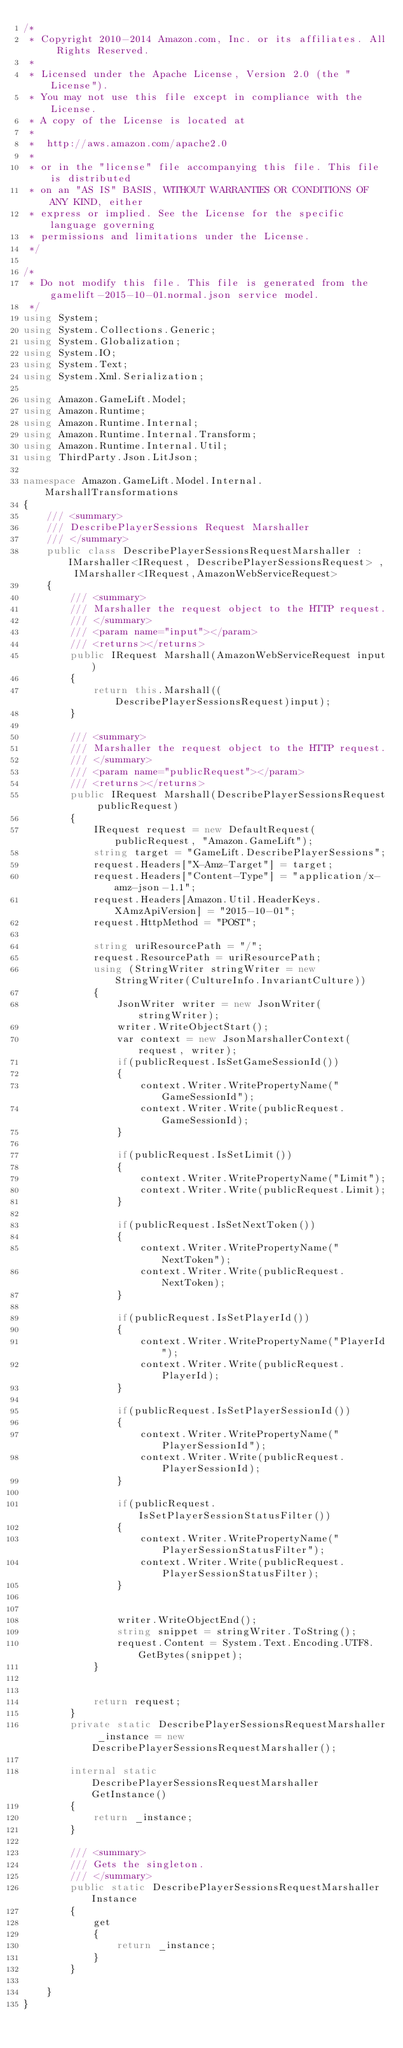<code> <loc_0><loc_0><loc_500><loc_500><_C#_>/*
 * Copyright 2010-2014 Amazon.com, Inc. or its affiliates. All Rights Reserved.
 * 
 * Licensed under the Apache License, Version 2.0 (the "License").
 * You may not use this file except in compliance with the License.
 * A copy of the License is located at
 * 
 *  http://aws.amazon.com/apache2.0
 * 
 * or in the "license" file accompanying this file. This file is distributed
 * on an "AS IS" BASIS, WITHOUT WARRANTIES OR CONDITIONS OF ANY KIND, either
 * express or implied. See the License for the specific language governing
 * permissions and limitations under the License.
 */

/*
 * Do not modify this file. This file is generated from the gamelift-2015-10-01.normal.json service model.
 */
using System;
using System.Collections.Generic;
using System.Globalization;
using System.IO;
using System.Text;
using System.Xml.Serialization;

using Amazon.GameLift.Model;
using Amazon.Runtime;
using Amazon.Runtime.Internal;
using Amazon.Runtime.Internal.Transform;
using Amazon.Runtime.Internal.Util;
using ThirdParty.Json.LitJson;

namespace Amazon.GameLift.Model.Internal.MarshallTransformations
{
    /// <summary>
    /// DescribePlayerSessions Request Marshaller
    /// </summary>       
    public class DescribePlayerSessionsRequestMarshaller : IMarshaller<IRequest, DescribePlayerSessionsRequest> , IMarshaller<IRequest,AmazonWebServiceRequest>
    {
        /// <summary>
        /// Marshaller the request object to the HTTP request.
        /// </summary>  
        /// <param name="input"></param>
        /// <returns></returns>
        public IRequest Marshall(AmazonWebServiceRequest input)
        {
            return this.Marshall((DescribePlayerSessionsRequest)input);
        }

        /// <summary>
        /// Marshaller the request object to the HTTP request.
        /// </summary>  
        /// <param name="publicRequest"></param>
        /// <returns></returns>
        public IRequest Marshall(DescribePlayerSessionsRequest publicRequest)
        {
            IRequest request = new DefaultRequest(publicRequest, "Amazon.GameLift");
            string target = "GameLift.DescribePlayerSessions";
            request.Headers["X-Amz-Target"] = target;
            request.Headers["Content-Type"] = "application/x-amz-json-1.1";
            request.Headers[Amazon.Util.HeaderKeys.XAmzApiVersion] = "2015-10-01";            
            request.HttpMethod = "POST";

            string uriResourcePath = "/";
            request.ResourcePath = uriResourcePath;
            using (StringWriter stringWriter = new StringWriter(CultureInfo.InvariantCulture))
            {
                JsonWriter writer = new JsonWriter(stringWriter);
                writer.WriteObjectStart();
                var context = new JsonMarshallerContext(request, writer);
                if(publicRequest.IsSetGameSessionId())
                {
                    context.Writer.WritePropertyName("GameSessionId");
                    context.Writer.Write(publicRequest.GameSessionId);
                }

                if(publicRequest.IsSetLimit())
                {
                    context.Writer.WritePropertyName("Limit");
                    context.Writer.Write(publicRequest.Limit);
                }

                if(publicRequest.IsSetNextToken())
                {
                    context.Writer.WritePropertyName("NextToken");
                    context.Writer.Write(publicRequest.NextToken);
                }

                if(publicRequest.IsSetPlayerId())
                {
                    context.Writer.WritePropertyName("PlayerId");
                    context.Writer.Write(publicRequest.PlayerId);
                }

                if(publicRequest.IsSetPlayerSessionId())
                {
                    context.Writer.WritePropertyName("PlayerSessionId");
                    context.Writer.Write(publicRequest.PlayerSessionId);
                }

                if(publicRequest.IsSetPlayerSessionStatusFilter())
                {
                    context.Writer.WritePropertyName("PlayerSessionStatusFilter");
                    context.Writer.Write(publicRequest.PlayerSessionStatusFilter);
                }

        
                writer.WriteObjectEnd();
                string snippet = stringWriter.ToString();
                request.Content = System.Text.Encoding.UTF8.GetBytes(snippet);
            }


            return request;
        }
        private static DescribePlayerSessionsRequestMarshaller _instance = new DescribePlayerSessionsRequestMarshaller();        

        internal static DescribePlayerSessionsRequestMarshaller GetInstance()
        {
            return _instance;
        }

        /// <summary>
        /// Gets the singleton.
        /// </summary>  
        public static DescribePlayerSessionsRequestMarshaller Instance
        {
            get
            {
                return _instance;
            }
        }

    }
}</code> 